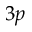Convert formula to latex. <formula><loc_0><loc_0><loc_500><loc_500>3 p</formula> 